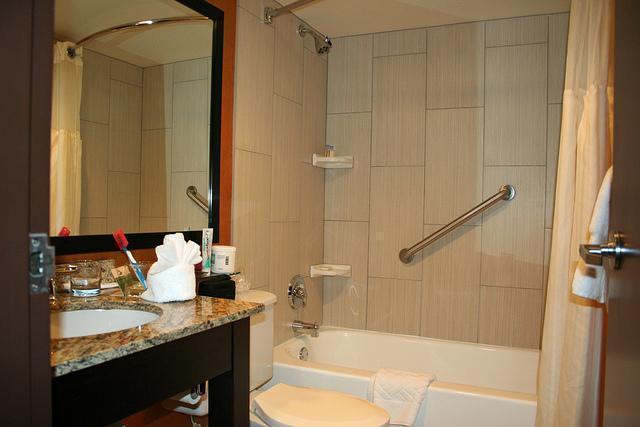What is the blue/white/red item by the sink?
Choose the right answer from the provided options to respond to the question.
Options: Toothbrush, bikini trimmer, toilet brush, nail clippers. Toothbrush. 